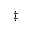Convert formula to latex. <formula><loc_0><loc_0><loc_500><loc_500>{ \ddag }</formula> 